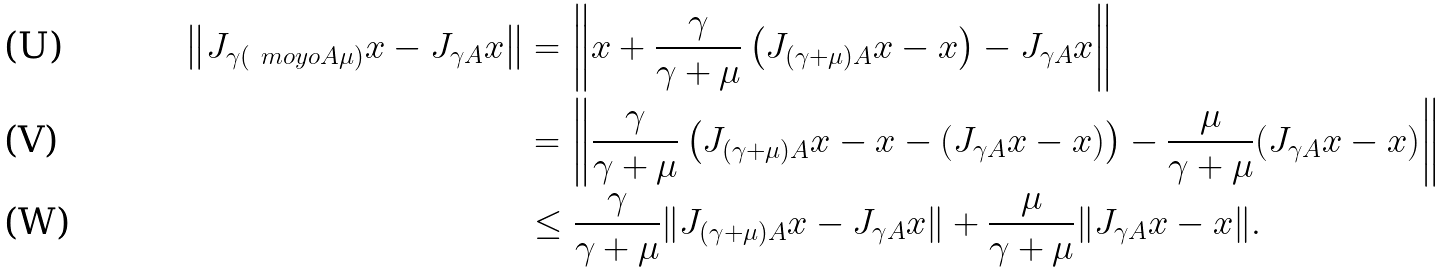<formula> <loc_0><loc_0><loc_500><loc_500>\left \| J _ { \gamma ( \ m o y o { A } { \mu } ) } x - J _ { \gamma A } x \right \| & = \left \| x + \frac { \gamma } { \gamma + \mu } \left ( J _ { ( \gamma + \mu ) A } x - x \right ) - J _ { \gamma A } x \right \| \\ & = \left \| \frac { \gamma } { \gamma + \mu } \left ( J _ { ( \gamma + \mu ) A } x - x - ( J _ { \gamma A } x - x ) \right ) - \frac { \mu } { \gamma + \mu } ( J _ { \gamma A } x - x ) \right \| \\ & \leq \frac { \gamma } { \gamma + \mu } \| J _ { ( \gamma + \mu ) A } x - J _ { \gamma A } x \| + \frac { \mu } { \gamma + \mu } \| J _ { \gamma A } x - x \| .</formula> 